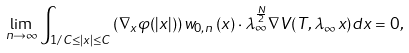<formula> <loc_0><loc_0><loc_500><loc_500>\lim _ { n \to \infty } \int _ { 1 / C \leq | x | \leq C } \left ( \nabla _ { x } \varphi ( | x | ) \right ) w _ { 0 , n } \left ( x \right ) \cdot \lambda _ { \infty } ^ { \frac { N } { 2 } } \nabla V ( T , \lambda _ { \infty } x ) d x = 0 ,</formula> 